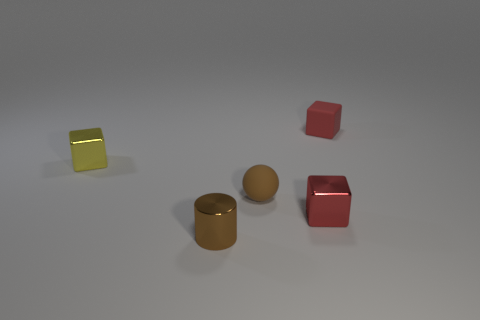Add 5 large green metal cylinders. How many objects exist? 10 Subtract all cubes. How many objects are left? 2 Add 1 small yellow blocks. How many small yellow blocks are left? 2 Add 5 brown metallic cylinders. How many brown metallic cylinders exist? 6 Subtract 1 yellow cubes. How many objects are left? 4 Subtract all red shiny blocks. Subtract all red rubber cubes. How many objects are left? 3 